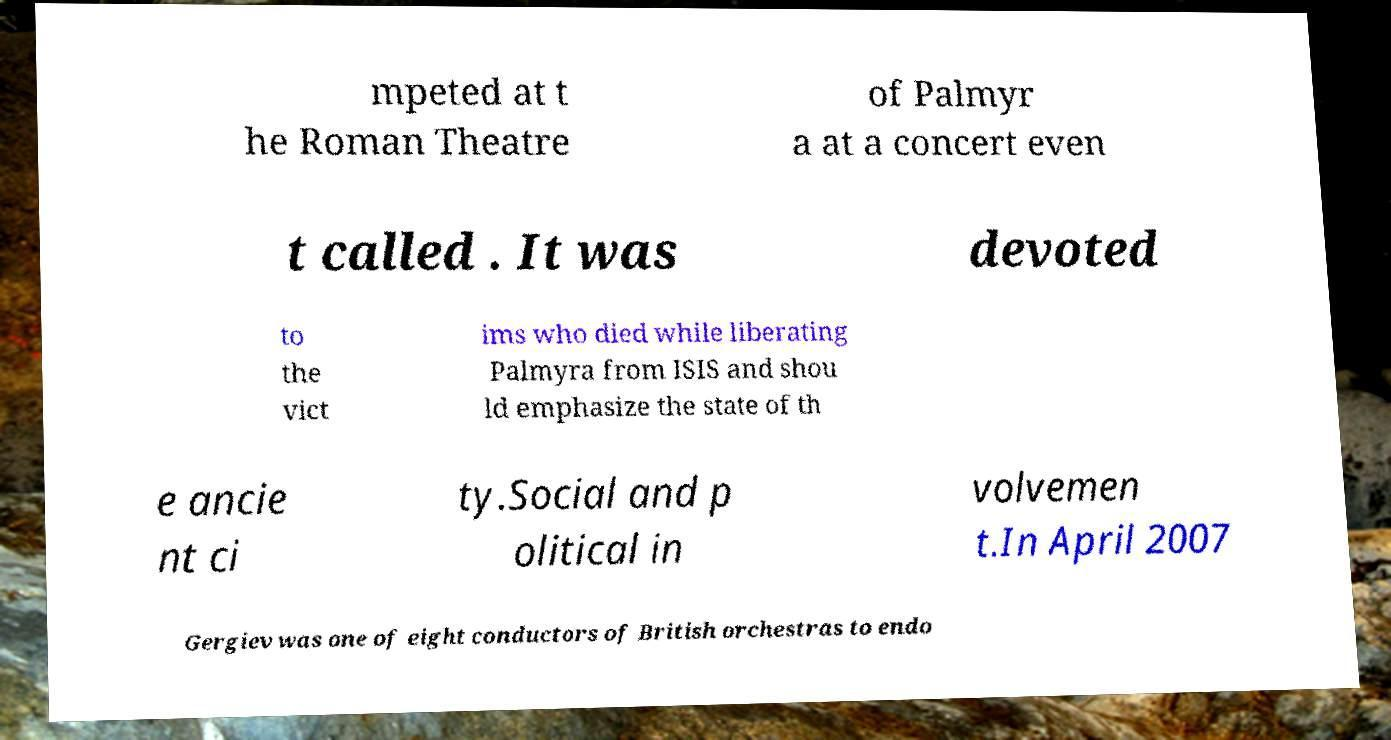Please read and relay the text visible in this image. What does it say? mpeted at t he Roman Theatre of Palmyr a at a concert even t called . It was devoted to the vict ims who died while liberating Palmyra from ISIS and shou ld emphasize the state of th e ancie nt ci ty.Social and p olitical in volvemen t.In April 2007 Gergiev was one of eight conductors of British orchestras to endo 